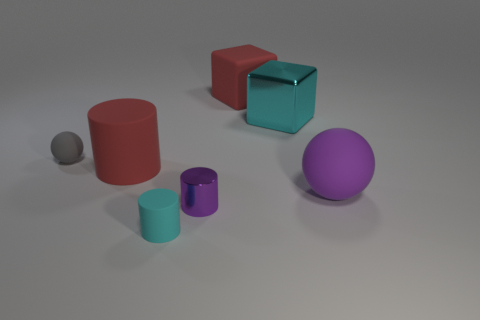Do the big cyan shiny object and the tiny purple shiny object have the same shape?
Your answer should be very brief. No. How many other things are there of the same material as the tiny cyan thing?
Offer a terse response. 4. How many matte things are the same shape as the purple metal thing?
Keep it short and to the point. 2. The cylinder that is both on the left side of the purple cylinder and behind the cyan matte cylinder is what color?
Your answer should be very brief. Red. How many small purple shiny cylinders are there?
Your answer should be compact. 1. Is the red matte cylinder the same size as the rubber block?
Your answer should be very brief. Yes. Are there any shiny cylinders that have the same color as the tiny matte cylinder?
Your answer should be very brief. No. There is a rubber thing on the right side of the big metal block; is its shape the same as the cyan shiny thing?
Provide a succinct answer. No. What number of purple cylinders have the same size as the gray object?
Ensure brevity in your answer.  1. There is a purple object on the right side of the purple cylinder; what number of tiny purple cylinders are on the right side of it?
Offer a very short reply. 0. 